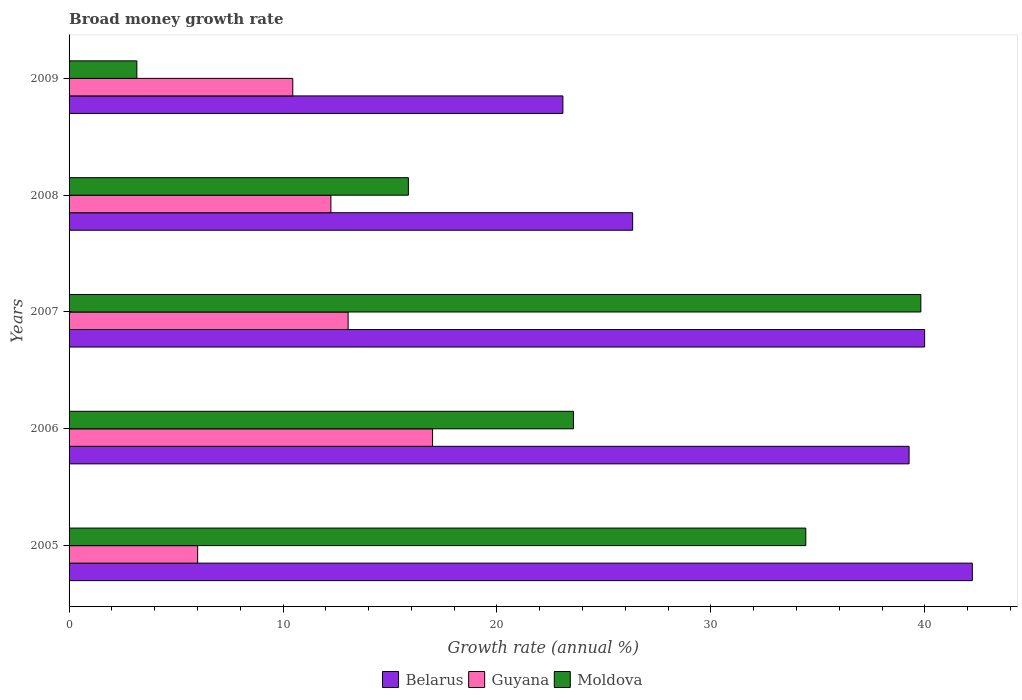How many different coloured bars are there?
Your response must be concise. 3. Are the number of bars per tick equal to the number of legend labels?
Offer a very short reply. Yes. Are the number of bars on each tick of the Y-axis equal?
Your response must be concise. Yes. How many bars are there on the 5th tick from the top?
Offer a terse response. 3. What is the growth rate in Moldova in 2007?
Provide a short and direct response. 39.81. Across all years, what is the maximum growth rate in Moldova?
Your response must be concise. 39.81. Across all years, what is the minimum growth rate in Moldova?
Make the answer very short. 3.17. What is the total growth rate in Moldova in the graph?
Your answer should be compact. 116.85. What is the difference between the growth rate in Moldova in 2005 and that in 2006?
Provide a short and direct response. 10.86. What is the difference between the growth rate in Moldova in 2006 and the growth rate in Belarus in 2007?
Your answer should be very brief. -16.41. What is the average growth rate in Belarus per year?
Provide a short and direct response. 34.18. In the year 2009, what is the difference between the growth rate in Guyana and growth rate in Belarus?
Your answer should be very brief. -12.62. What is the ratio of the growth rate in Moldova in 2005 to that in 2006?
Give a very brief answer. 1.46. Is the growth rate in Belarus in 2006 less than that in 2008?
Give a very brief answer. No. Is the difference between the growth rate in Guyana in 2005 and 2009 greater than the difference between the growth rate in Belarus in 2005 and 2009?
Offer a very short reply. No. What is the difference between the highest and the second highest growth rate in Guyana?
Offer a terse response. 3.95. What is the difference between the highest and the lowest growth rate in Belarus?
Your answer should be compact. 19.14. In how many years, is the growth rate in Guyana greater than the average growth rate in Guyana taken over all years?
Provide a succinct answer. 3. What does the 2nd bar from the top in 2009 represents?
Your response must be concise. Guyana. What does the 3rd bar from the bottom in 2009 represents?
Ensure brevity in your answer.  Moldova. What is the difference between two consecutive major ticks on the X-axis?
Ensure brevity in your answer.  10. Where does the legend appear in the graph?
Your answer should be very brief. Bottom center. How many legend labels are there?
Your answer should be compact. 3. How are the legend labels stacked?
Your answer should be compact. Horizontal. What is the title of the graph?
Keep it short and to the point. Broad money growth rate. What is the label or title of the X-axis?
Provide a succinct answer. Growth rate (annual %). What is the Growth rate (annual %) of Belarus in 2005?
Offer a terse response. 42.22. What is the Growth rate (annual %) of Guyana in 2005?
Offer a terse response. 6.01. What is the Growth rate (annual %) of Moldova in 2005?
Your answer should be compact. 34.43. What is the Growth rate (annual %) in Belarus in 2006?
Ensure brevity in your answer.  39.26. What is the Growth rate (annual %) of Guyana in 2006?
Offer a very short reply. 16.99. What is the Growth rate (annual %) in Moldova in 2006?
Give a very brief answer. 23.58. What is the Growth rate (annual %) in Belarus in 2007?
Your response must be concise. 39.99. What is the Growth rate (annual %) in Guyana in 2007?
Provide a succinct answer. 13.04. What is the Growth rate (annual %) in Moldova in 2007?
Ensure brevity in your answer.  39.81. What is the Growth rate (annual %) of Belarus in 2008?
Your answer should be very brief. 26.34. What is the Growth rate (annual %) of Guyana in 2008?
Offer a terse response. 12.24. What is the Growth rate (annual %) of Moldova in 2008?
Give a very brief answer. 15.86. What is the Growth rate (annual %) in Belarus in 2009?
Ensure brevity in your answer.  23.08. What is the Growth rate (annual %) in Guyana in 2009?
Keep it short and to the point. 10.46. What is the Growth rate (annual %) in Moldova in 2009?
Keep it short and to the point. 3.17. Across all years, what is the maximum Growth rate (annual %) of Belarus?
Offer a very short reply. 42.22. Across all years, what is the maximum Growth rate (annual %) in Guyana?
Your response must be concise. 16.99. Across all years, what is the maximum Growth rate (annual %) in Moldova?
Your answer should be compact. 39.81. Across all years, what is the minimum Growth rate (annual %) in Belarus?
Make the answer very short. 23.08. Across all years, what is the minimum Growth rate (annual %) in Guyana?
Keep it short and to the point. 6.01. Across all years, what is the minimum Growth rate (annual %) of Moldova?
Your answer should be compact. 3.17. What is the total Growth rate (annual %) of Belarus in the graph?
Ensure brevity in your answer.  170.89. What is the total Growth rate (annual %) of Guyana in the graph?
Give a very brief answer. 58.74. What is the total Growth rate (annual %) in Moldova in the graph?
Provide a short and direct response. 116.85. What is the difference between the Growth rate (annual %) in Belarus in 2005 and that in 2006?
Offer a terse response. 2.96. What is the difference between the Growth rate (annual %) in Guyana in 2005 and that in 2006?
Offer a terse response. -10.98. What is the difference between the Growth rate (annual %) in Moldova in 2005 and that in 2006?
Offer a terse response. 10.86. What is the difference between the Growth rate (annual %) of Belarus in 2005 and that in 2007?
Offer a very short reply. 2.23. What is the difference between the Growth rate (annual %) of Guyana in 2005 and that in 2007?
Your answer should be compact. -7.03. What is the difference between the Growth rate (annual %) of Moldova in 2005 and that in 2007?
Provide a succinct answer. -5.38. What is the difference between the Growth rate (annual %) in Belarus in 2005 and that in 2008?
Provide a succinct answer. 15.88. What is the difference between the Growth rate (annual %) of Guyana in 2005 and that in 2008?
Your answer should be very brief. -6.23. What is the difference between the Growth rate (annual %) of Moldova in 2005 and that in 2008?
Offer a very short reply. 18.57. What is the difference between the Growth rate (annual %) of Belarus in 2005 and that in 2009?
Make the answer very short. 19.14. What is the difference between the Growth rate (annual %) of Guyana in 2005 and that in 2009?
Offer a terse response. -4.45. What is the difference between the Growth rate (annual %) in Moldova in 2005 and that in 2009?
Offer a terse response. 31.27. What is the difference between the Growth rate (annual %) in Belarus in 2006 and that in 2007?
Give a very brief answer. -0.73. What is the difference between the Growth rate (annual %) in Guyana in 2006 and that in 2007?
Your answer should be very brief. 3.95. What is the difference between the Growth rate (annual %) in Moldova in 2006 and that in 2007?
Your response must be concise. -16.23. What is the difference between the Growth rate (annual %) of Belarus in 2006 and that in 2008?
Ensure brevity in your answer.  12.92. What is the difference between the Growth rate (annual %) of Guyana in 2006 and that in 2008?
Ensure brevity in your answer.  4.75. What is the difference between the Growth rate (annual %) of Moldova in 2006 and that in 2008?
Provide a short and direct response. 7.72. What is the difference between the Growth rate (annual %) in Belarus in 2006 and that in 2009?
Your response must be concise. 16.18. What is the difference between the Growth rate (annual %) in Guyana in 2006 and that in 2009?
Your answer should be compact. 6.53. What is the difference between the Growth rate (annual %) of Moldova in 2006 and that in 2009?
Give a very brief answer. 20.41. What is the difference between the Growth rate (annual %) of Belarus in 2007 and that in 2008?
Provide a succinct answer. 13.65. What is the difference between the Growth rate (annual %) of Guyana in 2007 and that in 2008?
Offer a very short reply. 0.8. What is the difference between the Growth rate (annual %) of Moldova in 2007 and that in 2008?
Ensure brevity in your answer.  23.95. What is the difference between the Growth rate (annual %) of Belarus in 2007 and that in 2009?
Ensure brevity in your answer.  16.91. What is the difference between the Growth rate (annual %) of Guyana in 2007 and that in 2009?
Provide a short and direct response. 2.59. What is the difference between the Growth rate (annual %) of Moldova in 2007 and that in 2009?
Give a very brief answer. 36.64. What is the difference between the Growth rate (annual %) of Belarus in 2008 and that in 2009?
Make the answer very short. 3.26. What is the difference between the Growth rate (annual %) in Guyana in 2008 and that in 2009?
Ensure brevity in your answer.  1.78. What is the difference between the Growth rate (annual %) of Moldova in 2008 and that in 2009?
Keep it short and to the point. 12.69. What is the difference between the Growth rate (annual %) of Belarus in 2005 and the Growth rate (annual %) of Guyana in 2006?
Provide a short and direct response. 25.23. What is the difference between the Growth rate (annual %) in Belarus in 2005 and the Growth rate (annual %) in Moldova in 2006?
Keep it short and to the point. 18.64. What is the difference between the Growth rate (annual %) of Guyana in 2005 and the Growth rate (annual %) of Moldova in 2006?
Ensure brevity in your answer.  -17.57. What is the difference between the Growth rate (annual %) in Belarus in 2005 and the Growth rate (annual %) in Guyana in 2007?
Give a very brief answer. 29.17. What is the difference between the Growth rate (annual %) in Belarus in 2005 and the Growth rate (annual %) in Moldova in 2007?
Ensure brevity in your answer.  2.41. What is the difference between the Growth rate (annual %) of Guyana in 2005 and the Growth rate (annual %) of Moldova in 2007?
Your answer should be compact. -33.8. What is the difference between the Growth rate (annual %) in Belarus in 2005 and the Growth rate (annual %) in Guyana in 2008?
Ensure brevity in your answer.  29.98. What is the difference between the Growth rate (annual %) of Belarus in 2005 and the Growth rate (annual %) of Moldova in 2008?
Your answer should be very brief. 26.36. What is the difference between the Growth rate (annual %) of Guyana in 2005 and the Growth rate (annual %) of Moldova in 2008?
Offer a very short reply. -9.85. What is the difference between the Growth rate (annual %) in Belarus in 2005 and the Growth rate (annual %) in Guyana in 2009?
Your response must be concise. 31.76. What is the difference between the Growth rate (annual %) of Belarus in 2005 and the Growth rate (annual %) of Moldova in 2009?
Offer a terse response. 39.05. What is the difference between the Growth rate (annual %) of Guyana in 2005 and the Growth rate (annual %) of Moldova in 2009?
Your response must be concise. 2.84. What is the difference between the Growth rate (annual %) in Belarus in 2006 and the Growth rate (annual %) in Guyana in 2007?
Ensure brevity in your answer.  26.22. What is the difference between the Growth rate (annual %) of Belarus in 2006 and the Growth rate (annual %) of Moldova in 2007?
Your answer should be compact. -0.55. What is the difference between the Growth rate (annual %) in Guyana in 2006 and the Growth rate (annual %) in Moldova in 2007?
Give a very brief answer. -22.82. What is the difference between the Growth rate (annual %) in Belarus in 2006 and the Growth rate (annual %) in Guyana in 2008?
Your response must be concise. 27.02. What is the difference between the Growth rate (annual %) in Belarus in 2006 and the Growth rate (annual %) in Moldova in 2008?
Ensure brevity in your answer.  23.4. What is the difference between the Growth rate (annual %) of Guyana in 2006 and the Growth rate (annual %) of Moldova in 2008?
Give a very brief answer. 1.13. What is the difference between the Growth rate (annual %) of Belarus in 2006 and the Growth rate (annual %) of Guyana in 2009?
Your response must be concise. 28.8. What is the difference between the Growth rate (annual %) in Belarus in 2006 and the Growth rate (annual %) in Moldova in 2009?
Provide a succinct answer. 36.09. What is the difference between the Growth rate (annual %) of Guyana in 2006 and the Growth rate (annual %) of Moldova in 2009?
Make the answer very short. 13.82. What is the difference between the Growth rate (annual %) of Belarus in 2007 and the Growth rate (annual %) of Guyana in 2008?
Make the answer very short. 27.75. What is the difference between the Growth rate (annual %) of Belarus in 2007 and the Growth rate (annual %) of Moldova in 2008?
Provide a succinct answer. 24.13. What is the difference between the Growth rate (annual %) in Guyana in 2007 and the Growth rate (annual %) in Moldova in 2008?
Make the answer very short. -2.82. What is the difference between the Growth rate (annual %) in Belarus in 2007 and the Growth rate (annual %) in Guyana in 2009?
Offer a very short reply. 29.53. What is the difference between the Growth rate (annual %) of Belarus in 2007 and the Growth rate (annual %) of Moldova in 2009?
Offer a very short reply. 36.82. What is the difference between the Growth rate (annual %) in Guyana in 2007 and the Growth rate (annual %) in Moldova in 2009?
Offer a terse response. 9.87. What is the difference between the Growth rate (annual %) of Belarus in 2008 and the Growth rate (annual %) of Guyana in 2009?
Provide a short and direct response. 15.88. What is the difference between the Growth rate (annual %) in Belarus in 2008 and the Growth rate (annual %) in Moldova in 2009?
Offer a terse response. 23.17. What is the difference between the Growth rate (annual %) of Guyana in 2008 and the Growth rate (annual %) of Moldova in 2009?
Make the answer very short. 9.07. What is the average Growth rate (annual %) of Belarus per year?
Your response must be concise. 34.18. What is the average Growth rate (annual %) in Guyana per year?
Provide a short and direct response. 11.75. What is the average Growth rate (annual %) of Moldova per year?
Offer a very short reply. 23.37. In the year 2005, what is the difference between the Growth rate (annual %) in Belarus and Growth rate (annual %) in Guyana?
Your response must be concise. 36.21. In the year 2005, what is the difference between the Growth rate (annual %) in Belarus and Growth rate (annual %) in Moldova?
Ensure brevity in your answer.  7.78. In the year 2005, what is the difference between the Growth rate (annual %) in Guyana and Growth rate (annual %) in Moldova?
Ensure brevity in your answer.  -28.42. In the year 2006, what is the difference between the Growth rate (annual %) of Belarus and Growth rate (annual %) of Guyana?
Offer a terse response. 22.27. In the year 2006, what is the difference between the Growth rate (annual %) in Belarus and Growth rate (annual %) in Moldova?
Your answer should be compact. 15.68. In the year 2006, what is the difference between the Growth rate (annual %) of Guyana and Growth rate (annual %) of Moldova?
Offer a very short reply. -6.59. In the year 2007, what is the difference between the Growth rate (annual %) in Belarus and Growth rate (annual %) in Guyana?
Make the answer very short. 26.95. In the year 2007, what is the difference between the Growth rate (annual %) in Belarus and Growth rate (annual %) in Moldova?
Make the answer very short. 0.18. In the year 2007, what is the difference between the Growth rate (annual %) in Guyana and Growth rate (annual %) in Moldova?
Ensure brevity in your answer.  -26.77. In the year 2008, what is the difference between the Growth rate (annual %) in Belarus and Growth rate (annual %) in Guyana?
Provide a short and direct response. 14.1. In the year 2008, what is the difference between the Growth rate (annual %) in Belarus and Growth rate (annual %) in Moldova?
Give a very brief answer. 10.48. In the year 2008, what is the difference between the Growth rate (annual %) of Guyana and Growth rate (annual %) of Moldova?
Your answer should be very brief. -3.62. In the year 2009, what is the difference between the Growth rate (annual %) of Belarus and Growth rate (annual %) of Guyana?
Give a very brief answer. 12.62. In the year 2009, what is the difference between the Growth rate (annual %) in Belarus and Growth rate (annual %) in Moldova?
Your answer should be compact. 19.91. In the year 2009, what is the difference between the Growth rate (annual %) of Guyana and Growth rate (annual %) of Moldova?
Provide a succinct answer. 7.29. What is the ratio of the Growth rate (annual %) in Belarus in 2005 to that in 2006?
Make the answer very short. 1.08. What is the ratio of the Growth rate (annual %) of Guyana in 2005 to that in 2006?
Make the answer very short. 0.35. What is the ratio of the Growth rate (annual %) in Moldova in 2005 to that in 2006?
Ensure brevity in your answer.  1.46. What is the ratio of the Growth rate (annual %) of Belarus in 2005 to that in 2007?
Make the answer very short. 1.06. What is the ratio of the Growth rate (annual %) in Guyana in 2005 to that in 2007?
Make the answer very short. 0.46. What is the ratio of the Growth rate (annual %) in Moldova in 2005 to that in 2007?
Provide a short and direct response. 0.86. What is the ratio of the Growth rate (annual %) in Belarus in 2005 to that in 2008?
Offer a terse response. 1.6. What is the ratio of the Growth rate (annual %) of Guyana in 2005 to that in 2008?
Your response must be concise. 0.49. What is the ratio of the Growth rate (annual %) of Moldova in 2005 to that in 2008?
Make the answer very short. 2.17. What is the ratio of the Growth rate (annual %) in Belarus in 2005 to that in 2009?
Give a very brief answer. 1.83. What is the ratio of the Growth rate (annual %) in Guyana in 2005 to that in 2009?
Provide a short and direct response. 0.57. What is the ratio of the Growth rate (annual %) in Moldova in 2005 to that in 2009?
Ensure brevity in your answer.  10.87. What is the ratio of the Growth rate (annual %) of Belarus in 2006 to that in 2007?
Provide a short and direct response. 0.98. What is the ratio of the Growth rate (annual %) of Guyana in 2006 to that in 2007?
Provide a succinct answer. 1.3. What is the ratio of the Growth rate (annual %) of Moldova in 2006 to that in 2007?
Your answer should be very brief. 0.59. What is the ratio of the Growth rate (annual %) in Belarus in 2006 to that in 2008?
Provide a short and direct response. 1.49. What is the ratio of the Growth rate (annual %) of Guyana in 2006 to that in 2008?
Provide a succinct answer. 1.39. What is the ratio of the Growth rate (annual %) in Moldova in 2006 to that in 2008?
Give a very brief answer. 1.49. What is the ratio of the Growth rate (annual %) of Belarus in 2006 to that in 2009?
Keep it short and to the point. 1.7. What is the ratio of the Growth rate (annual %) in Guyana in 2006 to that in 2009?
Ensure brevity in your answer.  1.62. What is the ratio of the Growth rate (annual %) of Moldova in 2006 to that in 2009?
Ensure brevity in your answer.  7.44. What is the ratio of the Growth rate (annual %) in Belarus in 2007 to that in 2008?
Your answer should be compact. 1.52. What is the ratio of the Growth rate (annual %) in Guyana in 2007 to that in 2008?
Keep it short and to the point. 1.07. What is the ratio of the Growth rate (annual %) in Moldova in 2007 to that in 2008?
Offer a very short reply. 2.51. What is the ratio of the Growth rate (annual %) in Belarus in 2007 to that in 2009?
Provide a succinct answer. 1.73. What is the ratio of the Growth rate (annual %) in Guyana in 2007 to that in 2009?
Give a very brief answer. 1.25. What is the ratio of the Growth rate (annual %) in Moldova in 2007 to that in 2009?
Ensure brevity in your answer.  12.57. What is the ratio of the Growth rate (annual %) of Belarus in 2008 to that in 2009?
Offer a terse response. 1.14. What is the ratio of the Growth rate (annual %) of Guyana in 2008 to that in 2009?
Give a very brief answer. 1.17. What is the ratio of the Growth rate (annual %) of Moldova in 2008 to that in 2009?
Your answer should be compact. 5.01. What is the difference between the highest and the second highest Growth rate (annual %) in Belarus?
Provide a short and direct response. 2.23. What is the difference between the highest and the second highest Growth rate (annual %) of Guyana?
Keep it short and to the point. 3.95. What is the difference between the highest and the second highest Growth rate (annual %) of Moldova?
Provide a short and direct response. 5.38. What is the difference between the highest and the lowest Growth rate (annual %) in Belarus?
Give a very brief answer. 19.14. What is the difference between the highest and the lowest Growth rate (annual %) of Guyana?
Ensure brevity in your answer.  10.98. What is the difference between the highest and the lowest Growth rate (annual %) in Moldova?
Make the answer very short. 36.64. 